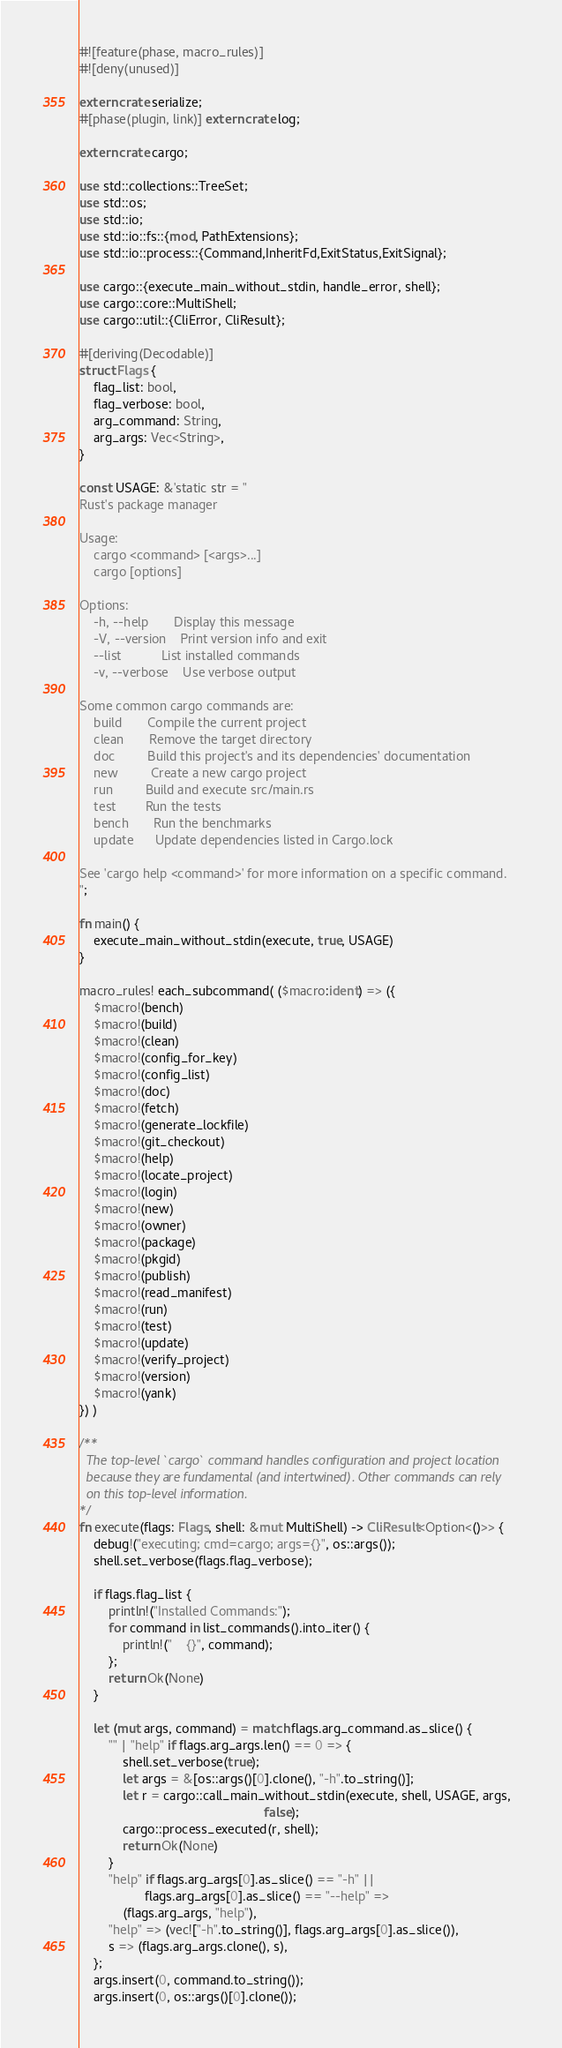<code> <loc_0><loc_0><loc_500><loc_500><_Rust_>#![feature(phase, macro_rules)]
#![deny(unused)]

extern crate serialize;
#[phase(plugin, link)] extern crate log;

extern crate cargo;

use std::collections::TreeSet;
use std::os;
use std::io;
use std::io::fs::{mod, PathExtensions};
use std::io::process::{Command,InheritFd,ExitStatus,ExitSignal};

use cargo::{execute_main_without_stdin, handle_error, shell};
use cargo::core::MultiShell;
use cargo::util::{CliError, CliResult};

#[deriving(Decodable)]
struct Flags {
    flag_list: bool,
    flag_verbose: bool,
    arg_command: String,
    arg_args: Vec<String>,
}

const USAGE: &'static str = "
Rust's package manager

Usage:
    cargo <command> [<args>...]
    cargo [options]

Options:
    -h, --help       Display this message
    -V, --version    Print version info and exit
    --list           List installed commands
    -v, --verbose    Use verbose output

Some common cargo commands are:
    build       Compile the current project
    clean       Remove the target directory
    doc         Build this project's and its dependencies' documentation
    new         Create a new cargo project
    run         Build and execute src/main.rs
    test        Run the tests
    bench       Run the benchmarks
    update      Update dependencies listed in Cargo.lock

See 'cargo help <command>' for more information on a specific command.
";

fn main() {
    execute_main_without_stdin(execute, true, USAGE)
}

macro_rules! each_subcommand( ($macro:ident) => ({
    $macro!(bench)
    $macro!(build)
    $macro!(clean)
    $macro!(config_for_key)
    $macro!(config_list)
    $macro!(doc)
    $macro!(fetch)
    $macro!(generate_lockfile)
    $macro!(git_checkout)
    $macro!(help)
    $macro!(locate_project)
    $macro!(login)
    $macro!(new)
    $macro!(owner)
    $macro!(package)
    $macro!(pkgid)
    $macro!(publish)
    $macro!(read_manifest)
    $macro!(run)
    $macro!(test)
    $macro!(update)
    $macro!(verify_project)
    $macro!(version)
    $macro!(yank)
}) )

/**
  The top-level `cargo` command handles configuration and project location
  because they are fundamental (and intertwined). Other commands can rely
  on this top-level information.
*/
fn execute(flags: Flags, shell: &mut MultiShell) -> CliResult<Option<()>> {
    debug!("executing; cmd=cargo; args={}", os::args());
    shell.set_verbose(flags.flag_verbose);

    if flags.flag_list {
        println!("Installed Commands:");
        for command in list_commands().into_iter() {
            println!("    {}", command);
        };
        return Ok(None)
    }

    let (mut args, command) = match flags.arg_command.as_slice() {
        "" | "help" if flags.arg_args.len() == 0 => {
            shell.set_verbose(true);
            let args = &[os::args()[0].clone(), "-h".to_string()];
            let r = cargo::call_main_without_stdin(execute, shell, USAGE, args,
                                                   false);
            cargo::process_executed(r, shell);
            return Ok(None)
        }
        "help" if flags.arg_args[0].as_slice() == "-h" ||
                  flags.arg_args[0].as_slice() == "--help" =>
            (flags.arg_args, "help"),
        "help" => (vec!["-h".to_string()], flags.arg_args[0].as_slice()),
        s => (flags.arg_args.clone(), s),
    };
    args.insert(0, command.to_string());
    args.insert(0, os::args()[0].clone());
</code> 